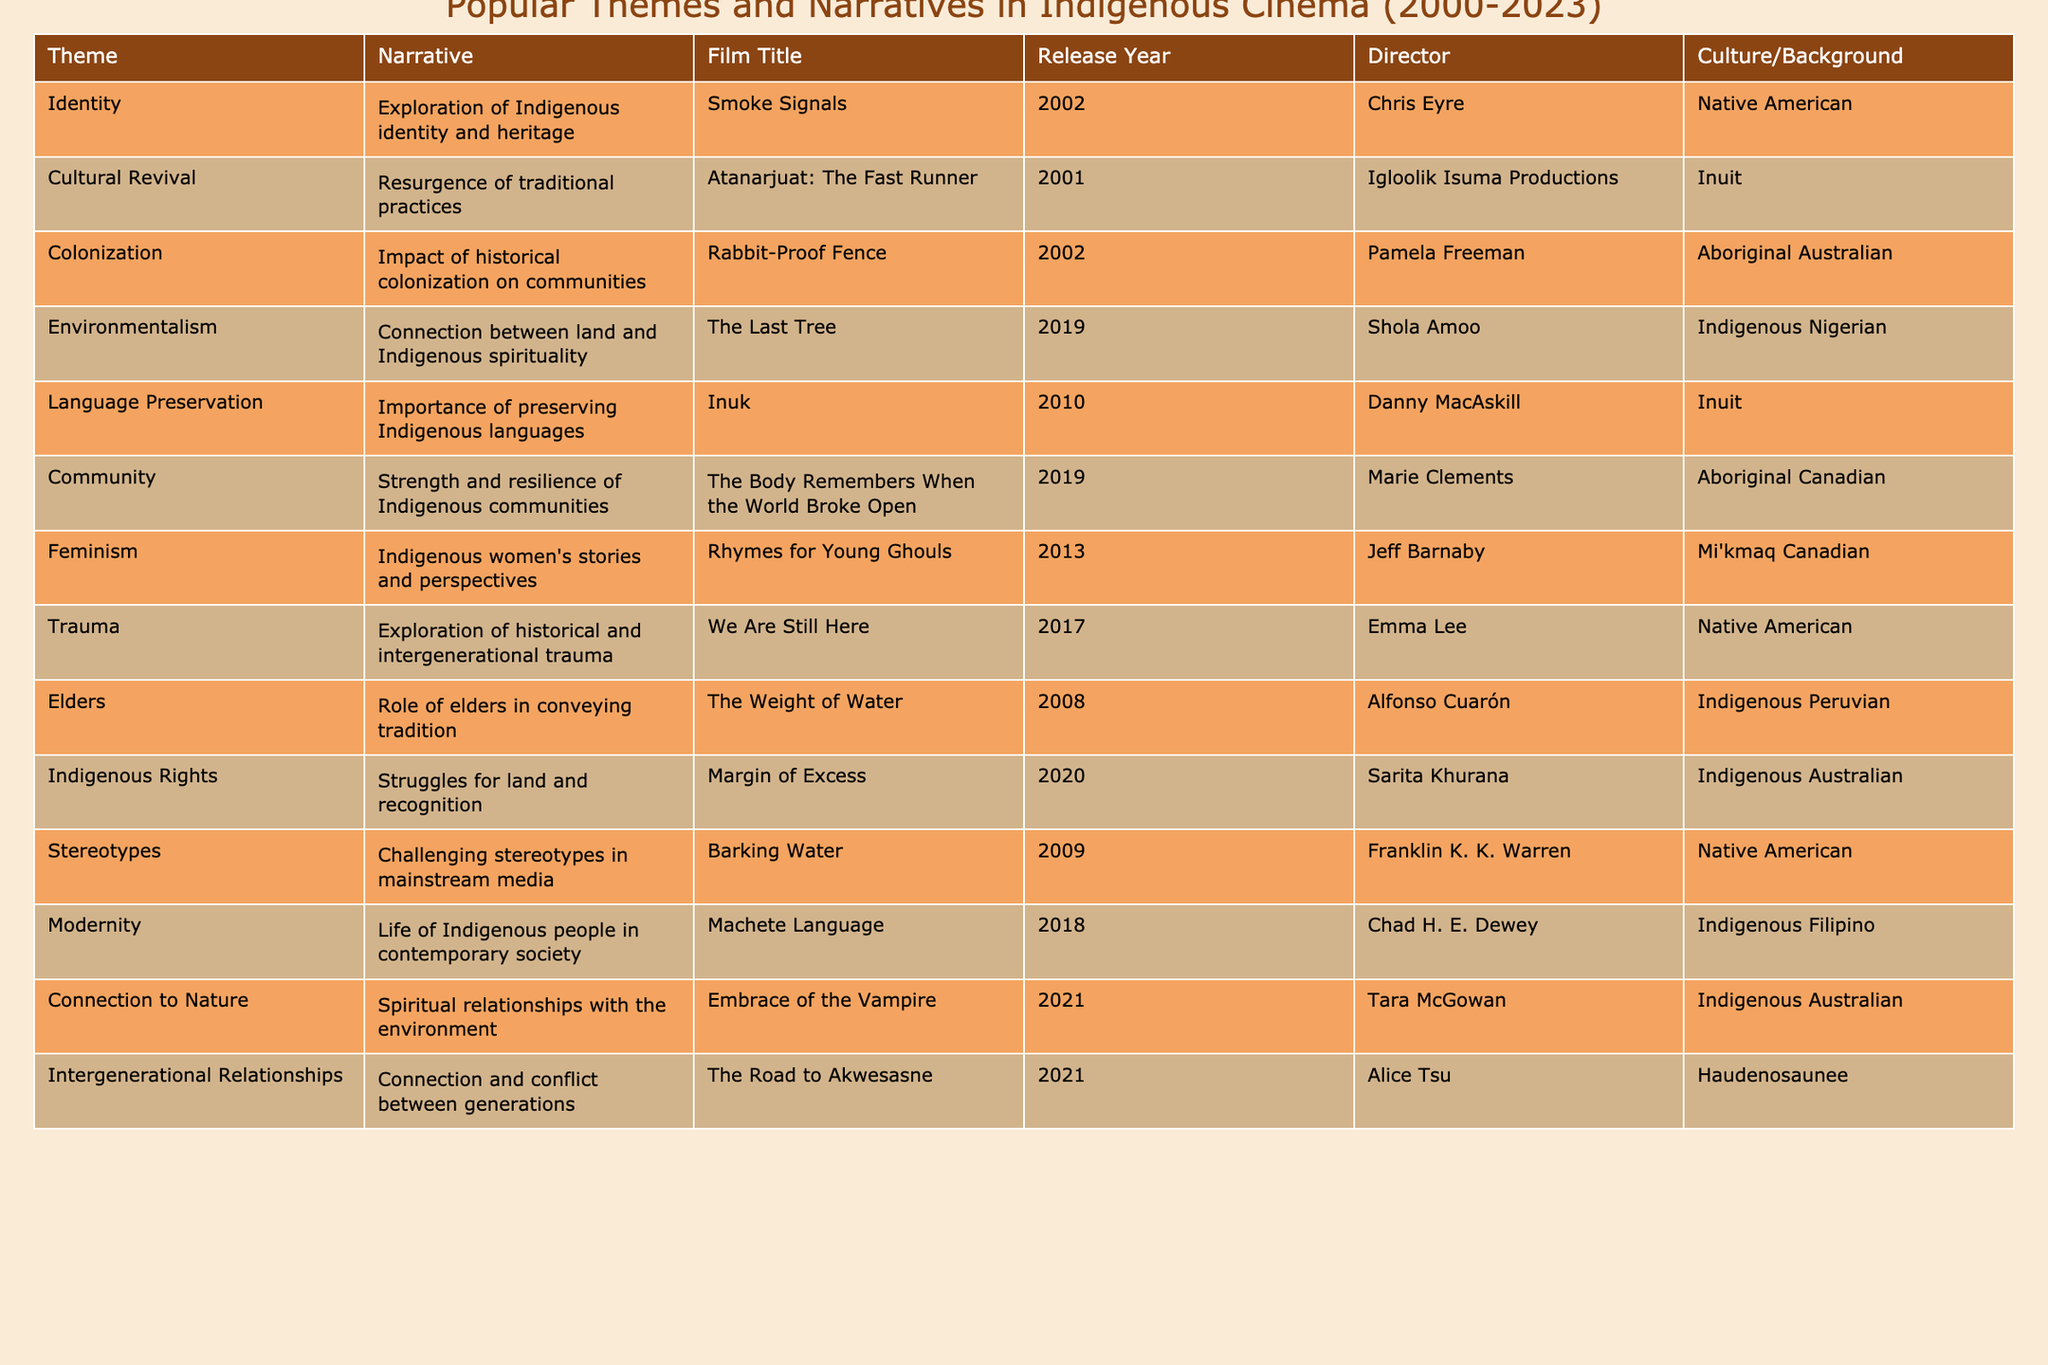What is the title of the film that explores Indigenous identity? The table indicates that "Smoke Signals" is the film that specifically addresses the theme of Indigenous identity.
Answer: Smoke Signals Which film was released the earliest among those listed? By reviewing the release years in the table, "Atanarjuat: The Fast Runner" from 2001 is the earliest release.
Answer: Atanarjuat: The Fast Runner How many films focus on the theme of trauma? The table shows one film titled "We Are Still Here" that focuses on the theme of trauma, indicating just one entry for this theme.
Answer: 1 Does any film address the importance of preserving Indigenous languages? The entry for "Inuk" in the table confirms that it focuses on the topic of language preservation, so the answer is yes.
Answer: Yes Which culture has the most films listed in the table? By counting the films per culture, Native American has three films ("Smoke Signals," "The Body Remembers When the World Broke Open," and "We Are Still Here"), which is more than any other culture listed.
Answer: Native American What narrative is associated with the film "Rabbit-Proof Fence"? According to the table, "Rabbit-Proof Fence" is associated with the narrative about the impact of historical colonization on communities.
Answer: Impact of historical colonization on communities Identify the most recent film listed in the table. By looking at the release years, "Margin of Excess," released in 2020, is the most recent film mentioned.
Answer: Margin of Excess What themes are addressed in films directed by Indigenous Australians? The films directed by Indigenous Australians in the table involve themes of colonization ("Rabbit-Proof Fence") and Indigenous rights ("Margin of Excess").
Answer: Colonization and Indigenous rights How many films explore themes related to the environment? The table lists two films that focus on environmental themes: "The Last Tree" and "Embrace of the Vampire." Therefore, there are two films under this category.
Answer: 2 What percentages of the films in the table focus on issues related to community? There is one film ("The Body Remembers When the World Broke Open") that focuses on community issues out of a total of eleven films, which calculates to about 9.09%.
Answer: 9.09% 